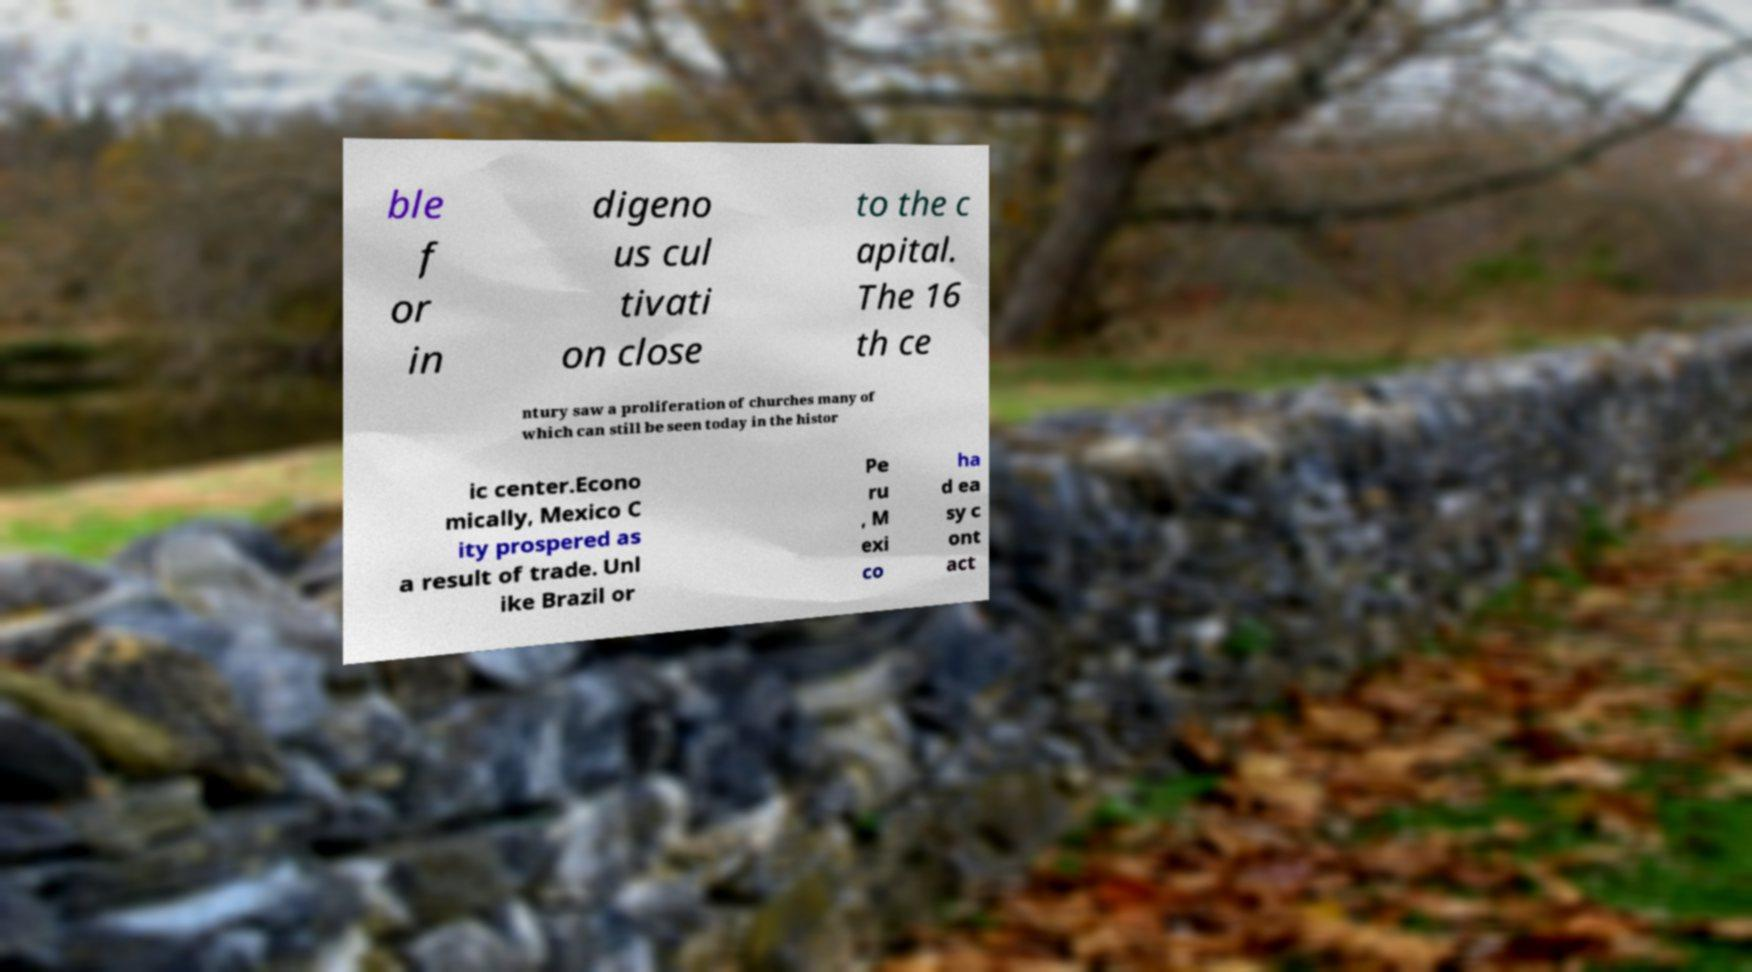What messages or text are displayed in this image? I need them in a readable, typed format. ble f or in digeno us cul tivati on close to the c apital. The 16 th ce ntury saw a proliferation of churches many of which can still be seen today in the histor ic center.Econo mically, Mexico C ity prospered as a result of trade. Unl ike Brazil or Pe ru , M exi co ha d ea sy c ont act 